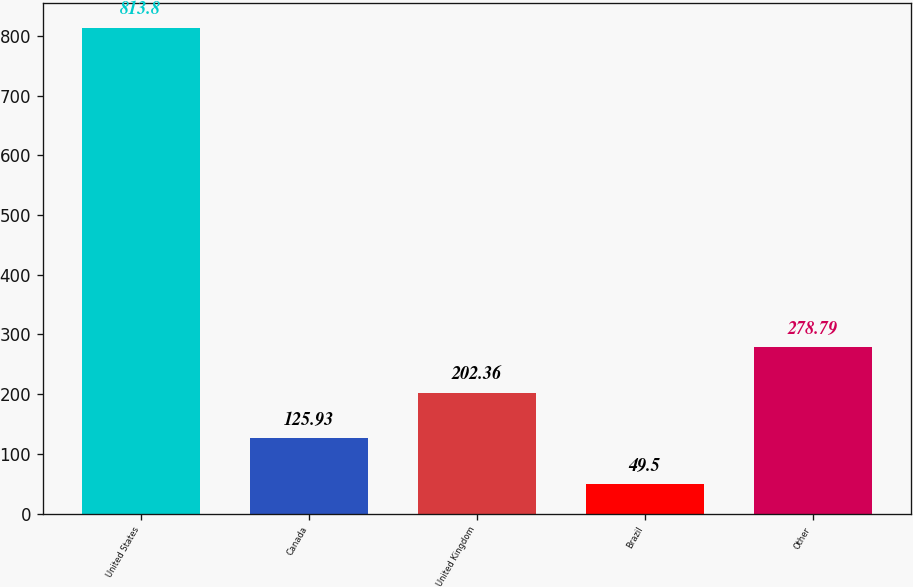Convert chart. <chart><loc_0><loc_0><loc_500><loc_500><bar_chart><fcel>United States<fcel>Canada<fcel>United Kingdom<fcel>Brazil<fcel>Other<nl><fcel>813.8<fcel>125.93<fcel>202.36<fcel>49.5<fcel>278.79<nl></chart> 